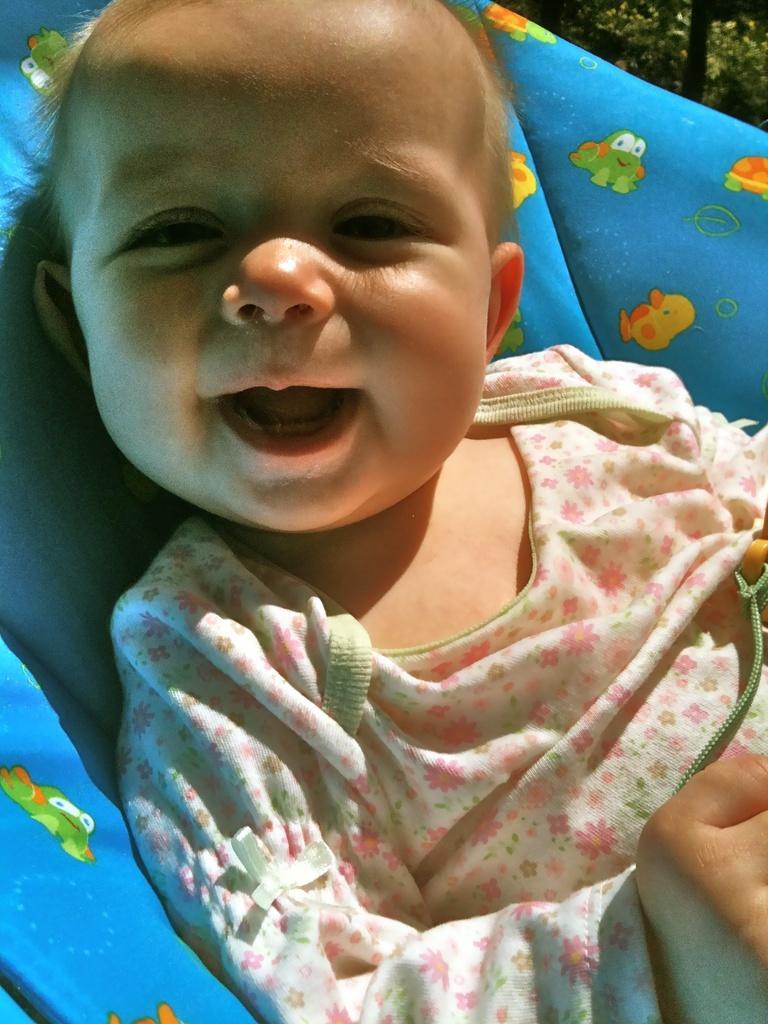Can you describe this image briefly? In this image we can see a baby on a bed. 